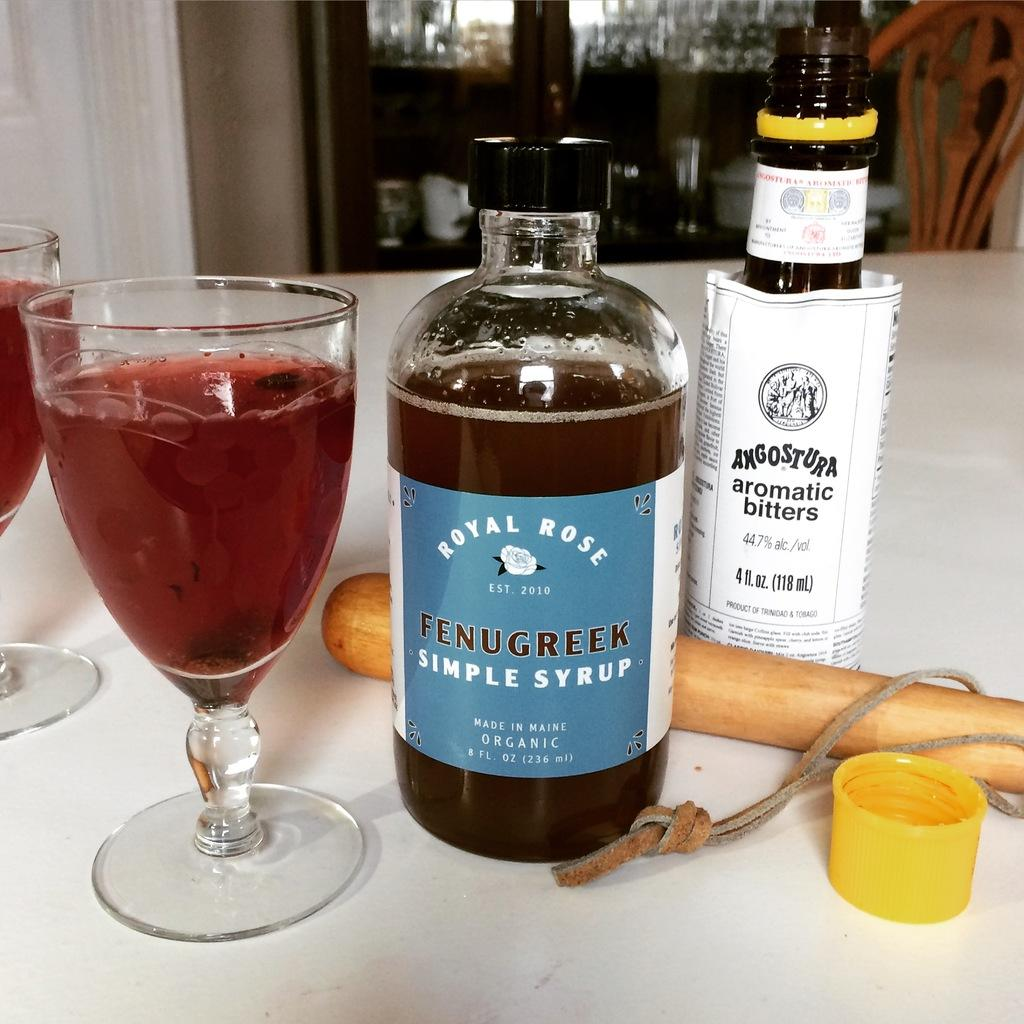<image>
Describe the image concisely. A mixed drink made from Fenugreek simple syrup and Angostura aromatic bitters. 